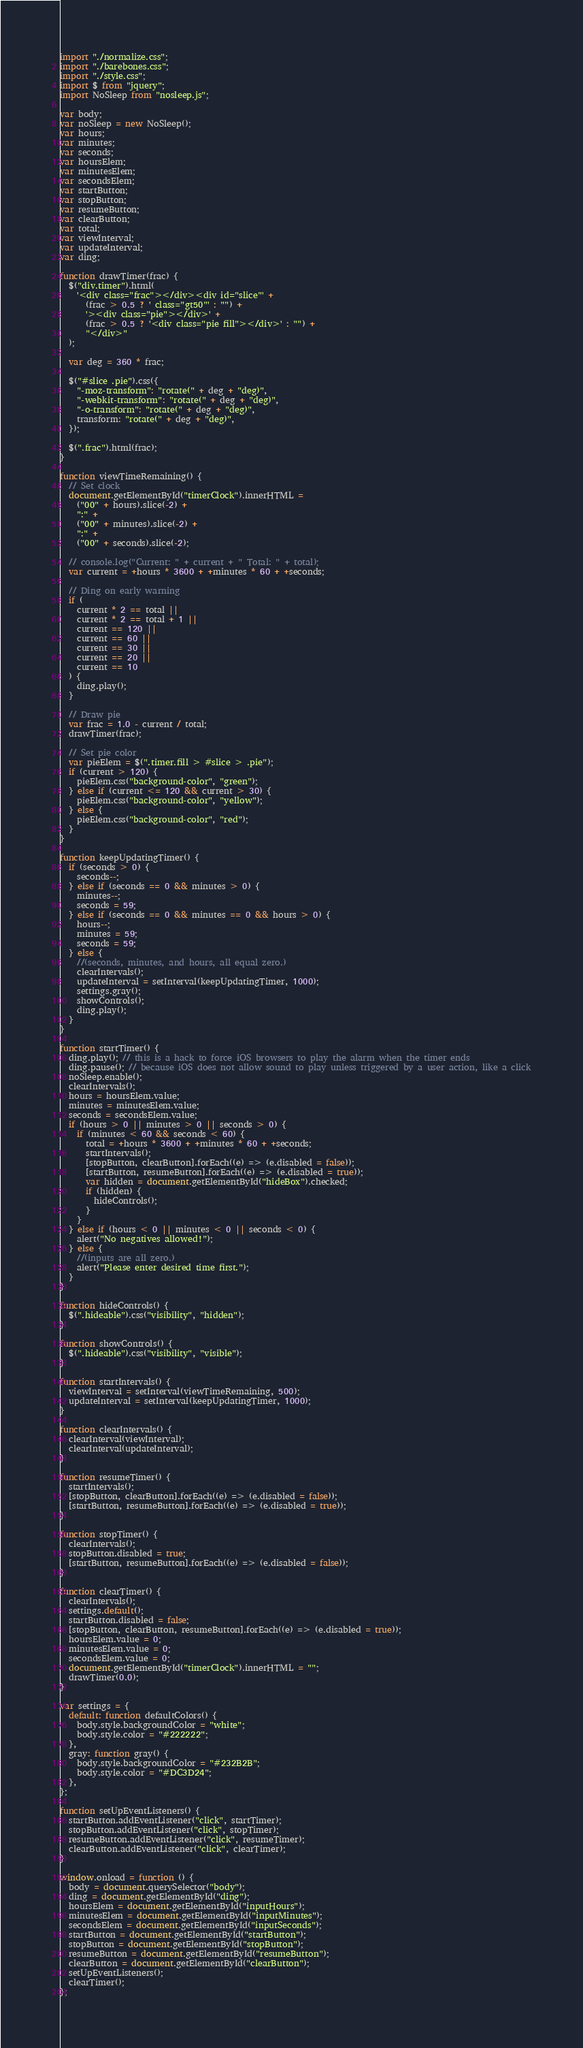<code> <loc_0><loc_0><loc_500><loc_500><_JavaScript_>import "./normalize.css";
import "./barebones.css";
import "./style.css";
import $ from "jquery";
import NoSleep from "nosleep.js";

var body;
var noSleep = new NoSleep();
var hours;
var minutes;
var seconds;
var hoursElem;
var minutesElem;
var secondsElem;
var startButton;
var stopButton;
var resumeButton;
var clearButton;
var total;
var viewInterval;
var updateInterval;
var ding;

function drawTimer(frac) {
  $("div.timer").html(
    '<div class="frac"></div><div id="slice"' +
      (frac > 0.5 ? ' class="gt50"' : "") +
      '><div class="pie"></div>' +
      (frac > 0.5 ? '<div class="pie fill"></div>' : "") +
      "</div>"
  );

  var deg = 360 * frac;

  $("#slice .pie").css({
    "-moz-transform": "rotate(" + deg + "deg)",
    "-webkit-transform": "rotate(" + deg + "deg)",
    "-o-transform": "rotate(" + deg + "deg)",
    transform: "rotate(" + deg + "deg)",
  });

  $(".frac").html(frac);
}

function viewTimeRemaining() {
  // Set clock
  document.getElementById("timerClock").innerHTML =
    ("00" + hours).slice(-2) +
    ":" +
    ("00" + minutes).slice(-2) +
    ":" +
    ("00" + seconds).slice(-2);

  // console.log("Current: " + current + " Total: " + total);
  var current = +hours * 3600 + +minutes * 60 + +seconds;

  // Ding on early warning
  if (
    current * 2 == total ||
    current * 2 == total + 1 ||
    current == 120 ||
    current == 60 ||
    current == 30 ||
    current == 20 ||
    current == 10
  ) {
    ding.play();
  }

  // Draw pie
  var frac = 1.0 - current / total;
  drawTimer(frac);

  // Set pie color
  var pieElem = $(".timer.fill > #slice > .pie");
  if (current > 120) {
    pieElem.css("background-color", "green");
  } else if (current <= 120 && current > 30) {
    pieElem.css("background-color", "yellow");
  } else {
    pieElem.css("background-color", "red");
  }
}

function keepUpdatingTimer() {
  if (seconds > 0) {
    seconds--;
  } else if (seconds == 0 && minutes > 0) {
    minutes--;
    seconds = 59;
  } else if (seconds == 0 && minutes == 0 && hours > 0) {
    hours--;
    minutes = 59;
    seconds = 59;
  } else {
    //(seconds, minutes, and hours, all equal zero.)
    clearIntervals();
    updateInterval = setInterval(keepUpdatingTimer, 1000);
    settings.gray();
    showControls();
    ding.play();
  }
}

function startTimer() {
  ding.play(); // this is a hack to force iOS browsers to play the alarm when the timer ends
  ding.pause(); // because iOS does not allow sound to play unless triggered by a user action, like a click
  noSleep.enable();
  clearIntervals();
  hours = hoursElem.value;
  minutes = minutesElem.value;
  seconds = secondsElem.value;
  if (hours > 0 || minutes > 0 || seconds > 0) {
    if (minutes < 60 && seconds < 60) {
      total = +hours * 3600 + +minutes * 60 + +seconds;
      startIntervals();
      [stopButton, clearButton].forEach((e) => (e.disabled = false));
      [startButton, resumeButton].forEach((e) => (e.disabled = true));
      var hidden = document.getElementById("hideBox").checked;
      if (hidden) {
        hideControls();
      }
    }
  } else if (hours < 0 || minutes < 0 || seconds < 0) {
    alert("No negatives allowed!");
  } else {
    //(inputs are all zero.)
    alert("Please enter desired time first.");
  }
}

function hideControls() {
  $(".hideable").css("visibility", "hidden");
}

function showControls() {
  $(".hideable").css("visibility", "visible");
}

function startIntervals() {
  viewInterval = setInterval(viewTimeRemaining, 500);
  updateInterval = setInterval(keepUpdatingTimer, 1000);
}

function clearIntervals() {
  clearInterval(viewInterval);
  clearInterval(updateInterval);
}

function resumeTimer() {
  startIntervals();
  [stopButton, clearButton].forEach((e) => (e.disabled = false));
  [startButton, resumeButton].forEach((e) => (e.disabled = true));
}

function stopTimer() {
  clearIntervals();
  stopButton.disabled = true;
  [startButton, resumeButton].forEach((e) => (e.disabled = false));
}

function clearTimer() {
  clearIntervals();
  settings.default();
  startButton.disabled = false;
  [stopButton, clearButton, resumeButton].forEach((e) => (e.disabled = true));
  hoursElem.value = 0;
  minutesElem.value = 0;
  secondsElem.value = 0;
  document.getElementById("timerClock").innerHTML = "";
  drawTimer(0.0);
}

var settings = {
  default: function defaultColors() {
    body.style.backgroundColor = "white";
    body.style.color = "#222222";
  },
  gray: function gray() {
    body.style.backgroundColor = "#232B2B";
    body.style.color = "#DC3D24";
  },
};

function setUpEventListeners() {
  startButton.addEventListener("click", startTimer);
  stopButton.addEventListener("click", stopTimer);
  resumeButton.addEventListener("click", resumeTimer);
  clearButton.addEventListener("click", clearTimer);
}

window.onload = function () {
  body = document.querySelector("body");
  ding = document.getElementById("ding");
  hoursElem = document.getElementById("inputHours");
  minutesElem = document.getElementById("inputMinutes");
  secondsElem = document.getElementById("inputSeconds");
  startButton = document.getElementById("startButton");
  stopButton = document.getElementById("stopButton");
  resumeButton = document.getElementById("resumeButton");
  clearButton = document.getElementById("clearButton");
  setUpEventListeners();
  clearTimer();
};
</code> 